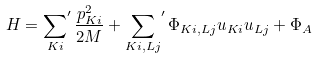<formula> <loc_0><loc_0><loc_500><loc_500>H = { \sum _ { K i } } ^ { \prime } \, \frac { p _ { K i } ^ { 2 } } { 2 M } + { \sum _ { K i , L j } } ^ { \prime } \, \Phi _ { K i , L j } u _ { K i } u _ { L j } + \Phi _ { A }</formula> 